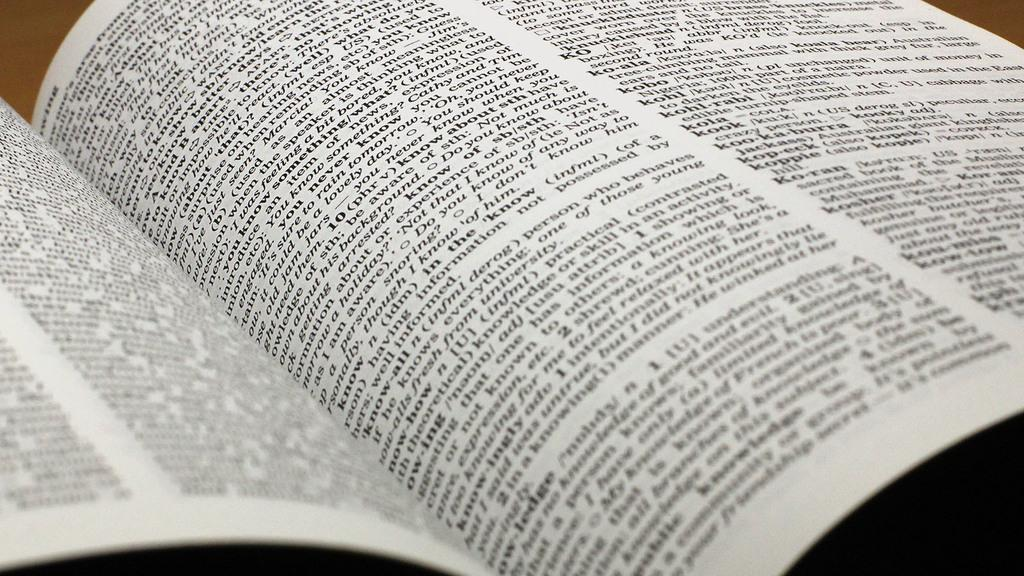<image>
Summarize the visual content of the image. A reference book is opened showing definitions for certain words like "Koran" and "Kosher." 